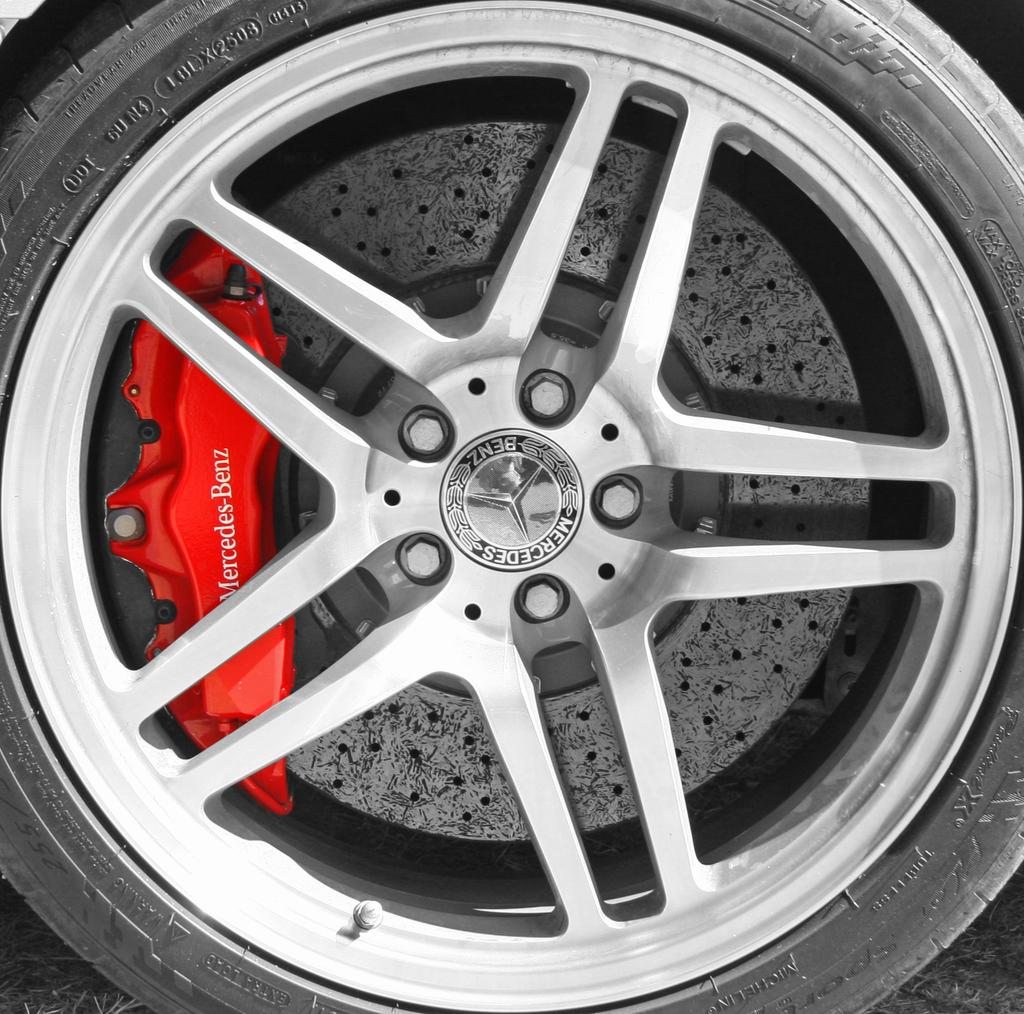What part of a car can be seen in the image? There is a wheel of a car in the image. What covers the wheel in the image? The wheel has a tire on it. Where is the guide for the playground located in the image? There is no guide or playground present in the image; it only features a wheel of a car with a tire on it. 